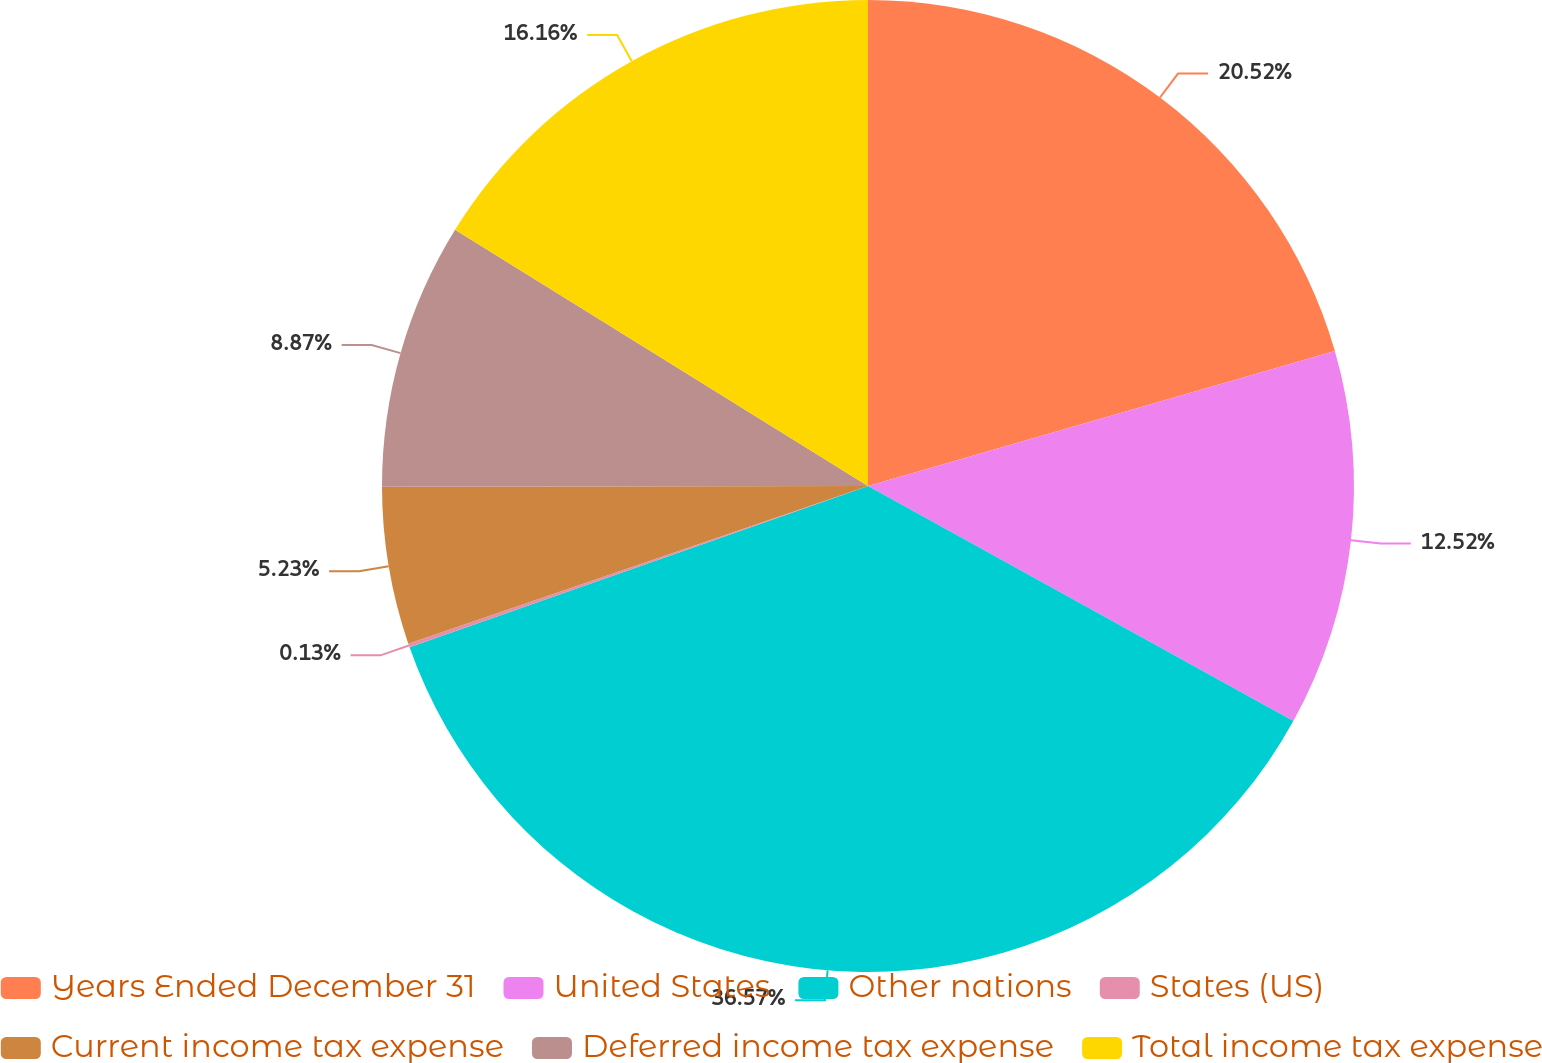Convert chart to OTSL. <chart><loc_0><loc_0><loc_500><loc_500><pie_chart><fcel>Years Ended December 31<fcel>United States<fcel>Other nations<fcel>States (US)<fcel>Current income tax expense<fcel>Deferred income tax expense<fcel>Total income tax expense<nl><fcel>20.52%<fcel>12.52%<fcel>36.58%<fcel>0.13%<fcel>5.23%<fcel>8.87%<fcel>16.16%<nl></chart> 